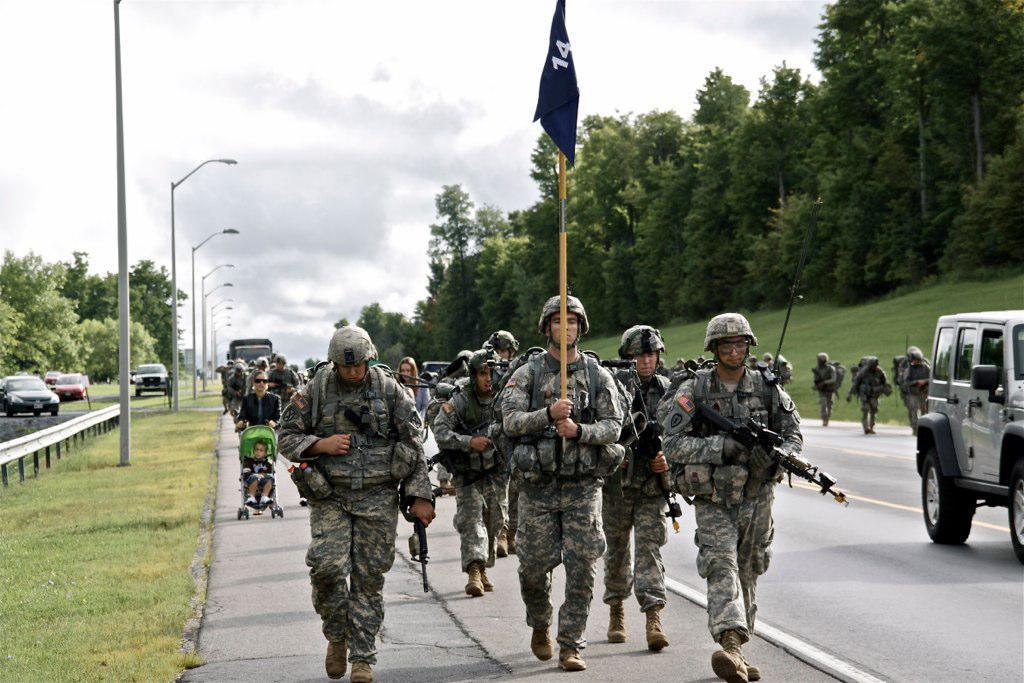Describe this image in one or two sentences. In this picture I can see few army men walking on the road, on the left there are cars and street lamps. There are trees on either side of this image, at the top there is the sky. 